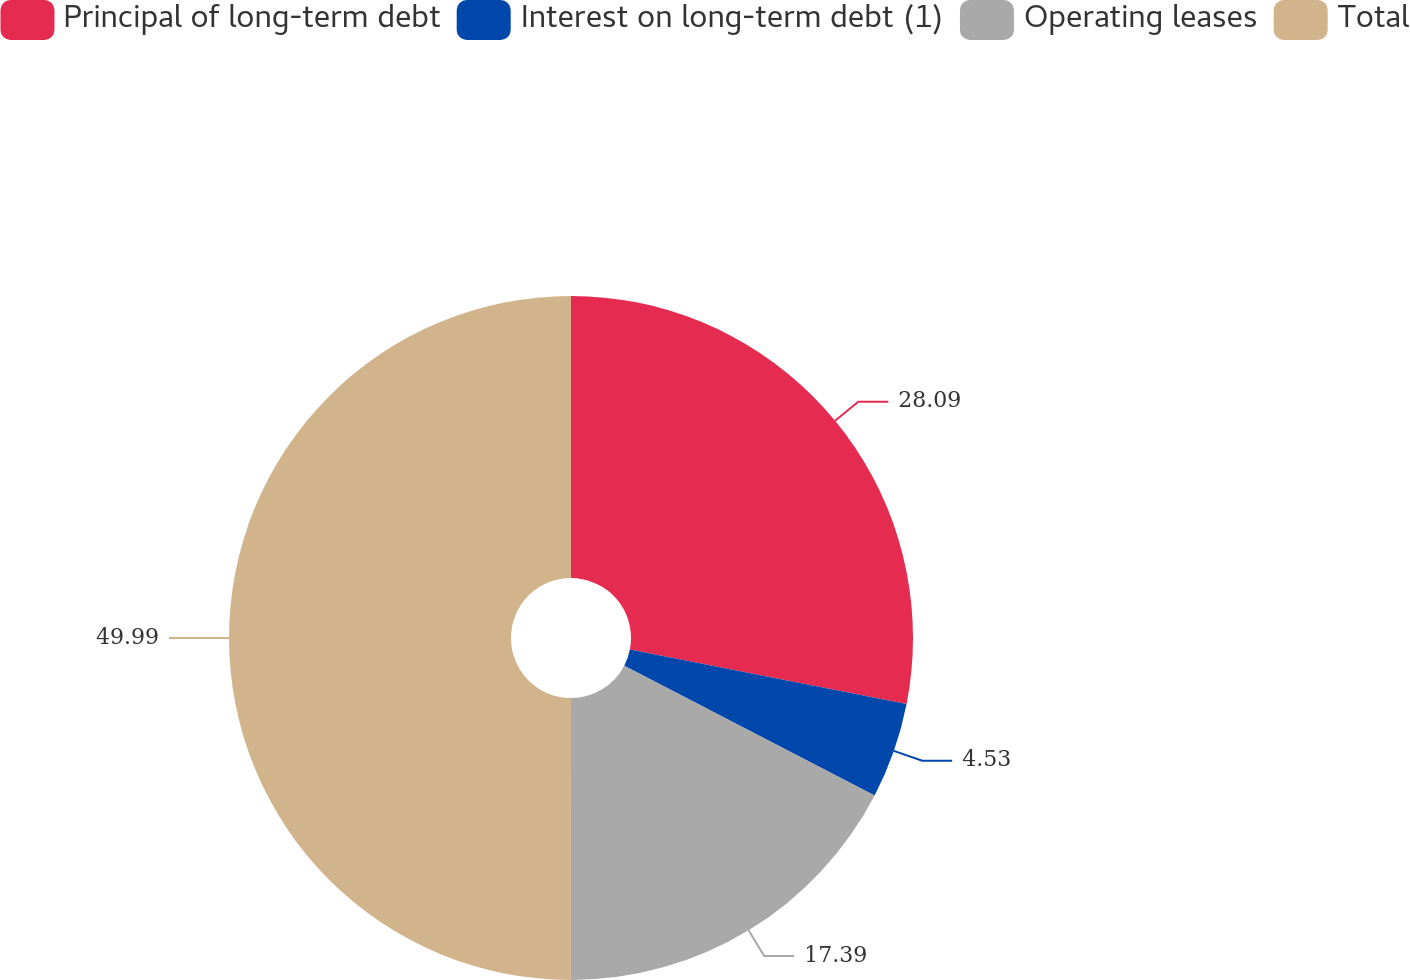<chart> <loc_0><loc_0><loc_500><loc_500><pie_chart><fcel>Principal of long-term debt<fcel>Interest on long-term debt (1)<fcel>Operating leases<fcel>Total<nl><fcel>28.09%<fcel>4.53%<fcel>17.39%<fcel>50.0%<nl></chart> 